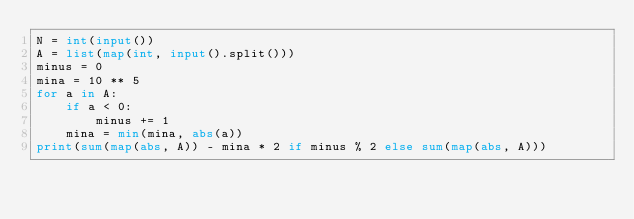Convert code to text. <code><loc_0><loc_0><loc_500><loc_500><_Python_>N = int(input())
A = list(map(int, input().split()))
minus = 0
mina = 10 ** 5
for a in A:
    if a < 0:
        minus += 1
    mina = min(mina, abs(a))
print(sum(map(abs, A)) - mina * 2 if minus % 2 else sum(map(abs, A)))
</code> 